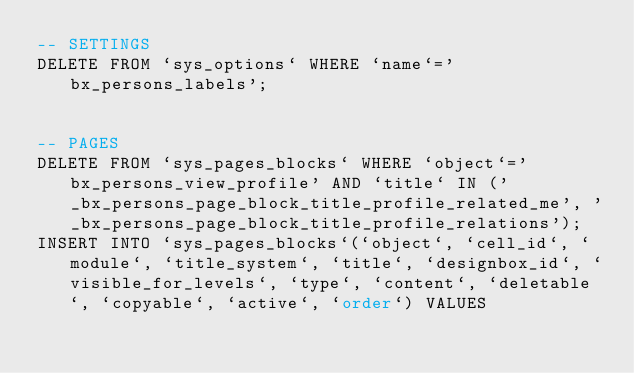<code> <loc_0><loc_0><loc_500><loc_500><_SQL_>-- SETTINGS
DELETE FROM `sys_options` WHERE `name`='bx_persons_labels';


-- PAGES
DELETE FROM `sys_pages_blocks` WHERE `object`='bx_persons_view_profile' AND `title` IN ('_bx_persons_page_block_title_profile_related_me', '_bx_persons_page_block_title_profile_relations');
INSERT INTO `sys_pages_blocks`(`object`, `cell_id`, `module`, `title_system`, `title`, `designbox_id`, `visible_for_levels`, `type`, `content`, `deletable`, `copyable`, `active`, `order`) VALUES</code> 